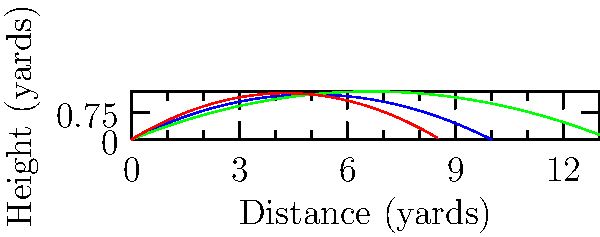As a quarterback aiming to showcase your versatility, which type of pass would you choose for a play requiring maximum height at 5 yards from the line of scrimmage? To determine which pass reaches the maximum height at 5 yards, we need to compare the height of each trajectory at this point:

1. Short Pass (blue):
   $y = -0.05x^2 + 0.5x$
   At $x = 5$: $y = -0.05(5)^2 + 0.5(5) = -1.25 + 2.5 = 1.25$ yards

2. Medium Pass (green):
   $y = -0.03x^2 + 0.4x$
   At $x = 5$: $y = -0.03(5)^2 + 0.4(5) = -0.75 + 2 = 1.25$ yards

3. Deep Pass (red):
   $y = -0.07x^2 + 0.6x$
   At $x = 5$: $y = -0.07(5)^2 + 0.6(5) = -1.75 + 3 = 1.25$ yards

Interestingly, all passes reach the same height (1.25 yards) at 5 yards from the line of scrimmage. However, the Deep Pass (red) has the steepest initial trajectory, reaching this height more quickly and continuing to rise beyond this point, while the other passes begin to descend.
Answer: Deep Pass (red) 